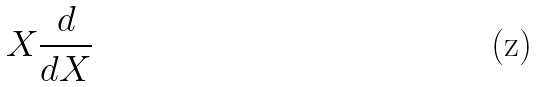Convert formula to latex. <formula><loc_0><loc_0><loc_500><loc_500>X \frac { d } { d X }</formula> 